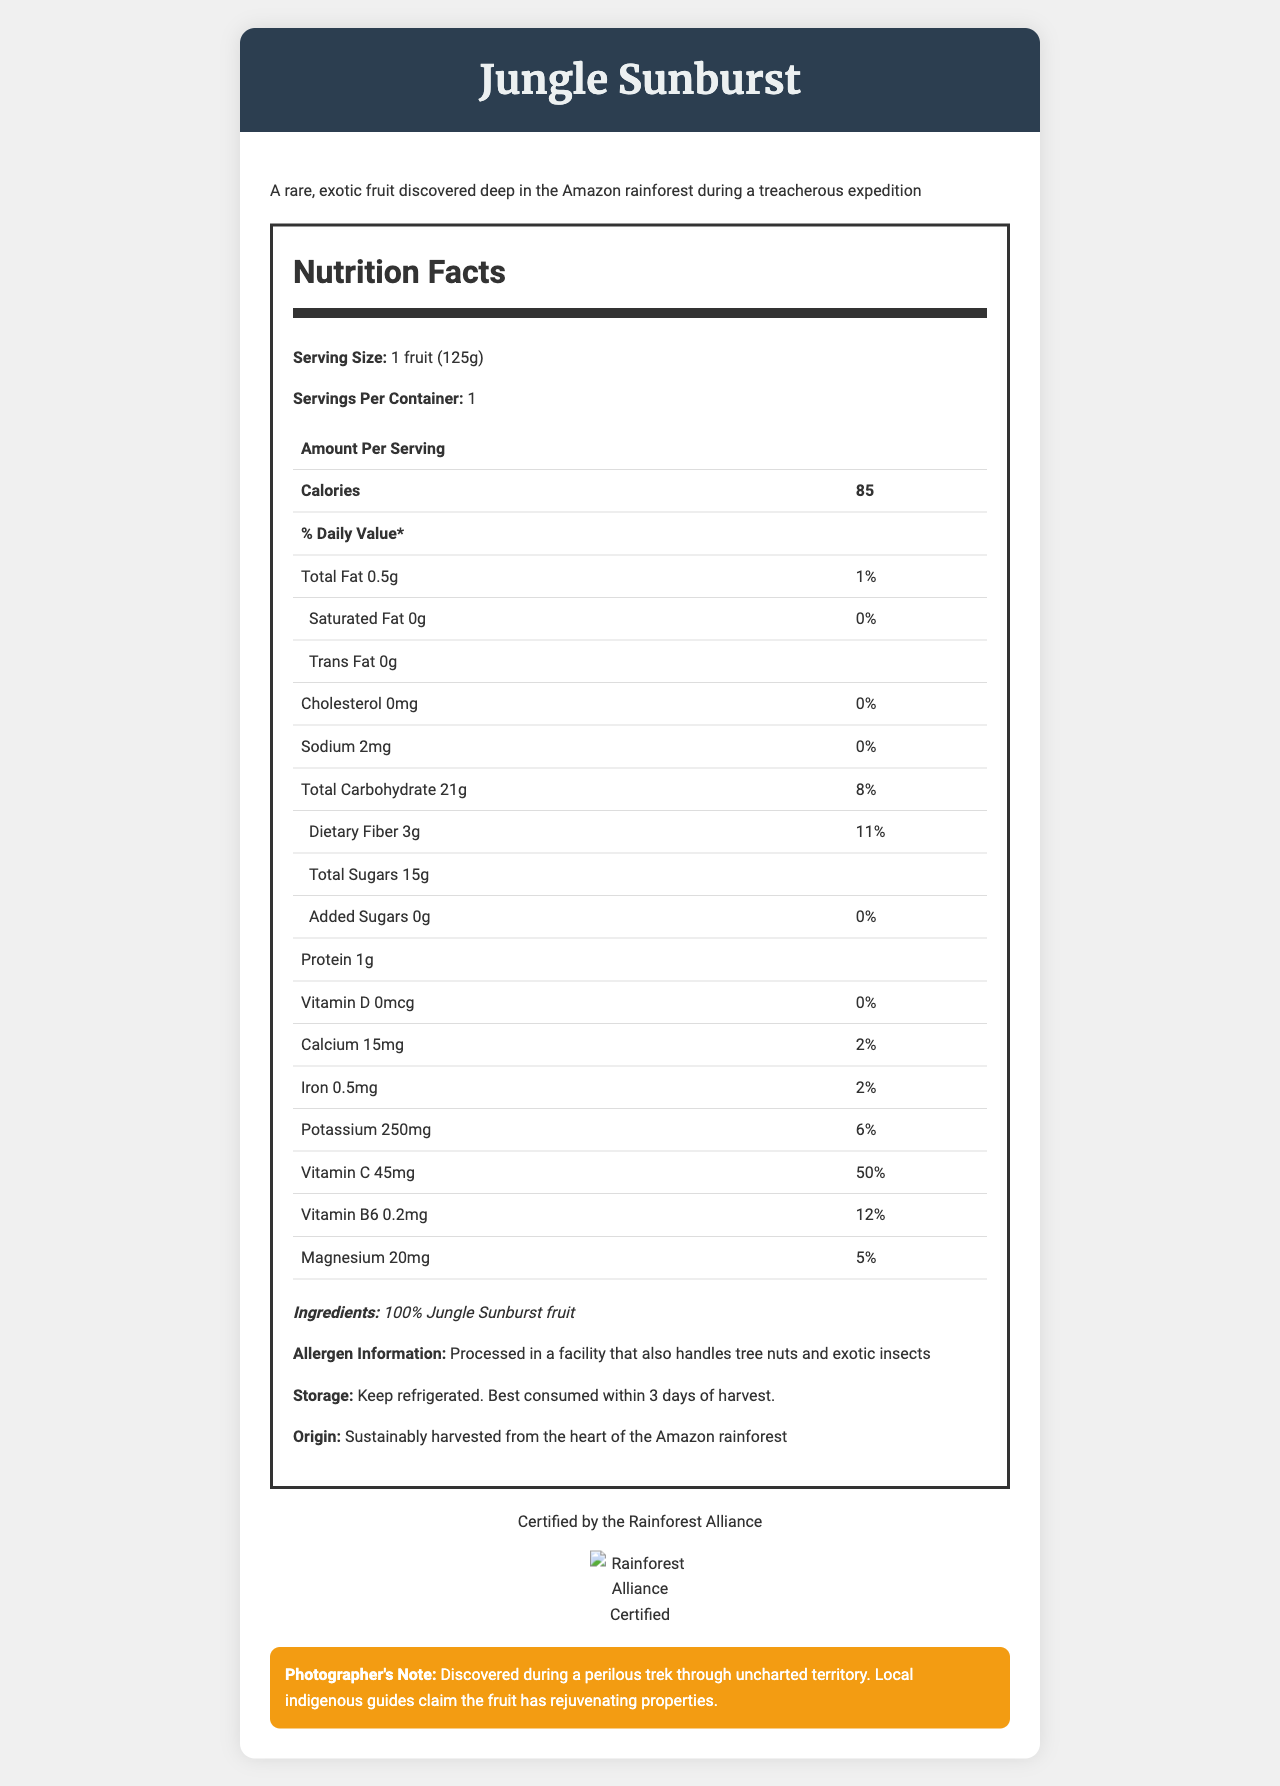what is the serving size of the Jungle Sunburst fruit? The serving size is clearly stated in the Nutrition Facts section of the document: "Serving Size: 1 fruit (125g)."
Answer: 1 fruit (125g) how many calories does one Jungle Sunburst fruit contain? The Nutrition Facts section indicates that one serving, or one fruit, contains 85 calories.
Answer: 85 calories what is the total fat content per serving and its daily value percentage? The document specifies "Total Fat: 0.5g" with "% Daily Value: 1%" in the Nutrition Facts table.
Answer: 0.5g, 1% how much dietary fiber does the Jungle Sunburst fruit have per serving? The Nutrition Facts section lists the dietary fiber content as 3g per serving.
Answer: 3g which vitamin has the highest daily value percentage in the Jungle Sunburst fruit? A. Vitamin D B. Vitamin C C. Magnesium D. Iron The document shows that Vitamin C has a daily value percentage of 50%, which is the highest among the listed vitamins and minerals.
Answer: B. Vitamin C are there any added sugars in the Jungle Sunburst fruit? (Yes/No) The Nutrition Facts section explicitly states "Added Sugars: 0g" with a % daily value of 0%.
Answer: No what is the source of the Jungle Sunburst fruit? The description and origin section of the document specify that the fruit is sustainably harvested from the heart of the Amazon rainforest.
Answer: The heart of the Amazon rainforest which mineral contributes 6% of the daily value in the Jungle Sunburst fruit? A. Calcium B. Magnesium C. Potassium D. Iron The document lists Potassium with a daily value percentage of 6%.
Answer: C. Potassium how should the Jungle Sunburst fruit be stored? The storage instructions in the document advise to keep the fruit refrigerated and to consume it within 3 days of harvest.
Answer: Keep refrigerated. Best consumed within 3 days of harvest. provide a summary of the document The detailed summary describes all the essential sections of the document including nutritional information, storage, origin, certification, and the photographer's note.
Answer: The document contains detailed information about the Jungle Sunburst fruit, discovered in the Amazon rainforest. It includes a description of the serving size, calorie count, and nutritional values including vitamins and minerals. It highlights that the fruit contains no added sugars, minimal fats, and a good amount of dietary fiber. The document also provides allergen information, storage recommendations, and certification details. Additionally, a note from the photographer describes the fruit’s discovery and local beliefs about its rejuvenating properties. how much sodium is in one serving of the Jungle Sunburst fruit? The document specifies that there is 2mg of sodium per serving in the Nutrition Facts section.
Answer: 2mg is the document certified by an external organization? (True/False) The document indicates that the Jungle Sunburst fruit is "Certified by the Rainforest Alliance."
Answer: True did the photographer who discovered the Jungle Sunburst fruit make any special notes about it? The Photographer's Note section mentions these details about the discovery and the local beliefs regarding the fruit.
Answer: Yes, the photographer noted that the fruit was discovered during a perilous trek through uncharted territory and that local guides believe it has rejuvenating properties. what specific allergens are mentioned in the document? The allergen information states that the product was processed in a facility that handles tree nuts and exotic insects.
Answer: Tree nuts and exotic insects what is the iron content and its daily value percentage in the Jungle Sunburst fruit? The Nutrition Facts section lists Iron as 0.5mg with a daily value percentage of 2%.
Answer: 0.5mg, 2% how many grams of protein does one Jungle Sunburst fruit offer? A. 1g B. 2g C. 3g D. 0.5g The document specifies that there is 1g of protein per serving in the Nutrition Facts section.
Answer: A. 1g does the Jungle Sunburst fruit contain any cholesterol? The Nutrition Facts section states that it has 0mg of cholesterol and a 0% daily value.
Answer: No what time of the day was the Jungle Sunburst fruit discovered? The document does not provide any information about the specific time of day when the fruit was discovered.
Answer: I don't know 